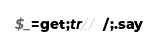<code> <loc_0><loc_0><loc_500><loc_500><_Perl_>$_=get;tr/,/ /;.say</code> 